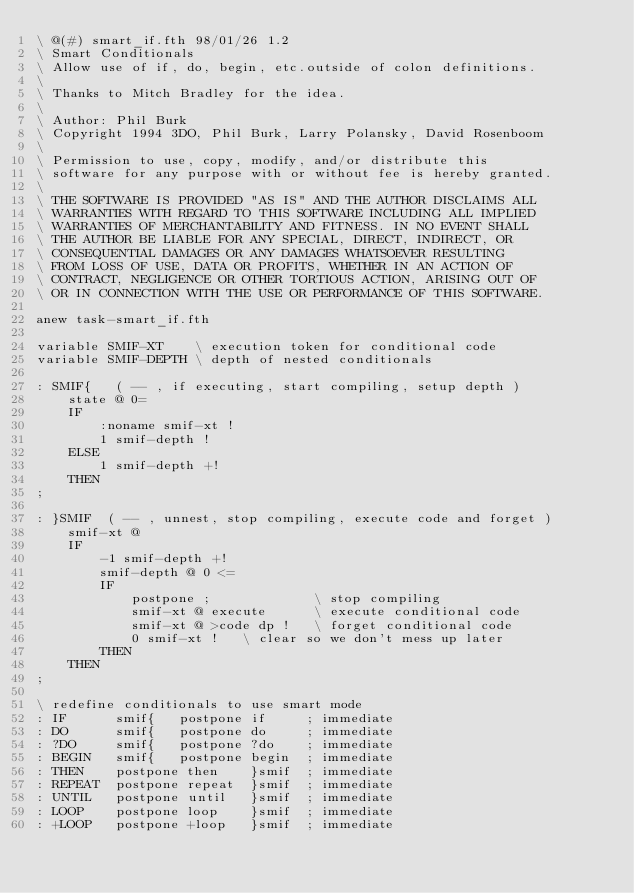<code> <loc_0><loc_0><loc_500><loc_500><_Forth_>\ @(#) smart_if.fth 98/01/26 1.2
\ Smart Conditionals
\ Allow use of if, do, begin, etc.outside of colon definitions.
\
\ Thanks to Mitch Bradley for the idea.
\
\ Author: Phil Burk
\ Copyright 1994 3DO, Phil Burk, Larry Polansky, David Rosenboom
\
\ Permission to use, copy, modify, and/or distribute this
\ software for any purpose with or without fee is hereby granted.
\
\ THE SOFTWARE IS PROVIDED "AS IS" AND THE AUTHOR DISCLAIMS ALL
\ WARRANTIES WITH REGARD TO THIS SOFTWARE INCLUDING ALL IMPLIED
\ WARRANTIES OF MERCHANTABILITY AND FITNESS. IN NO EVENT SHALL
\ THE AUTHOR BE LIABLE FOR ANY SPECIAL, DIRECT, INDIRECT, OR
\ CONSEQUENTIAL DAMAGES OR ANY DAMAGES WHATSOEVER RESULTING
\ FROM LOSS OF USE, DATA OR PROFITS, WHETHER IN AN ACTION OF
\ CONTRACT, NEGLIGENCE OR OTHER TORTIOUS ACTION, ARISING OUT OF
\ OR IN CONNECTION WITH THE USE OR PERFORMANCE OF THIS SOFTWARE.

anew task-smart_if.fth

variable SMIF-XT    \ execution token for conditional code
variable SMIF-DEPTH \ depth of nested conditionals

: SMIF{   ( -- , if executing, start compiling, setup depth )
    state @ 0=
    IF
        :noname smif-xt !
        1 smif-depth !
    ELSE
        1 smif-depth +!
    THEN
;

: }SMIF  ( -- , unnest, stop compiling, execute code and forget )
    smif-xt @
    IF
        -1 smif-depth +!
        smif-depth @ 0 <=
        IF
            postpone ;             \ stop compiling
            smif-xt @ execute      \ execute conditional code
            smif-xt @ >code dp !   \ forget conditional code
            0 smif-xt !   \ clear so we don't mess up later
        THEN
    THEN
;

\ redefine conditionals to use smart mode
: IF      smif{   postpone if     ; immediate
: DO      smif{   postpone do     ; immediate
: ?DO     smif{   postpone ?do    ; immediate
: BEGIN   smif{   postpone begin  ; immediate
: THEN    postpone then    }smif  ; immediate
: REPEAT  postpone repeat  }smif  ; immediate
: UNTIL   postpone until   }smif  ; immediate
: LOOP    postpone loop    }smif  ; immediate
: +LOOP   postpone +loop   }smif  ; immediate
</code> 